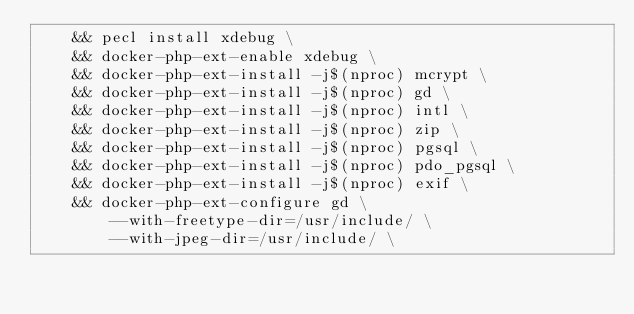Convert code to text. <code><loc_0><loc_0><loc_500><loc_500><_Dockerfile_>    && pecl install xdebug \
    && docker-php-ext-enable xdebug \
    && docker-php-ext-install -j$(nproc) mcrypt \
    && docker-php-ext-install -j$(nproc) gd \
    && docker-php-ext-install -j$(nproc) intl \
    && docker-php-ext-install -j$(nproc) zip \
    && docker-php-ext-install -j$(nproc) pgsql \
    && docker-php-ext-install -j$(nproc) pdo_pgsql \
    && docker-php-ext-install -j$(nproc) exif \
    && docker-php-ext-configure gd \
        --with-freetype-dir=/usr/include/ \
        --with-jpeg-dir=/usr/include/ \</code> 